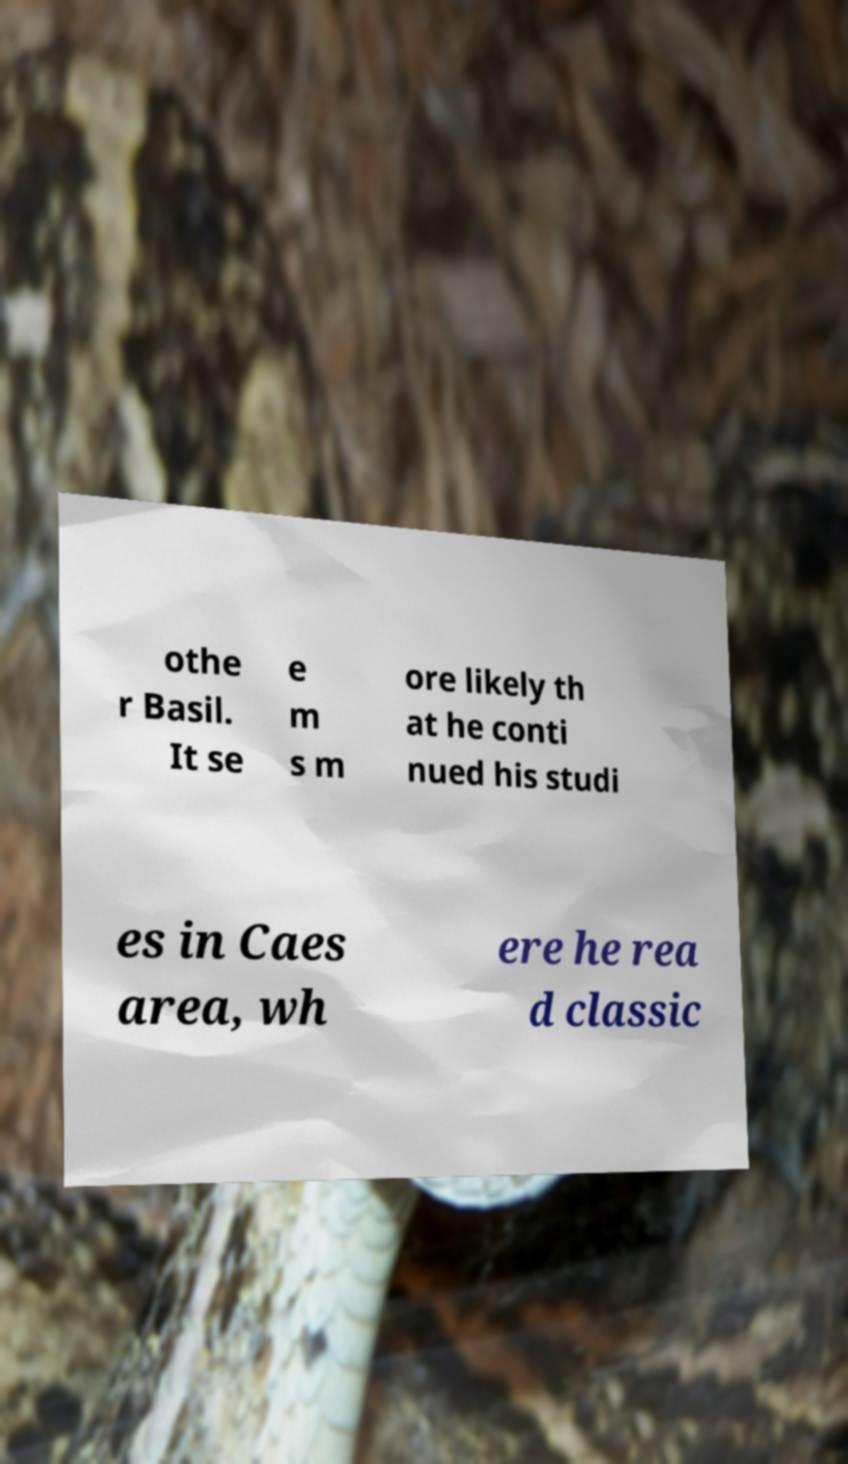Please read and relay the text visible in this image. What does it say? othe r Basil. It se e m s m ore likely th at he conti nued his studi es in Caes area, wh ere he rea d classic 